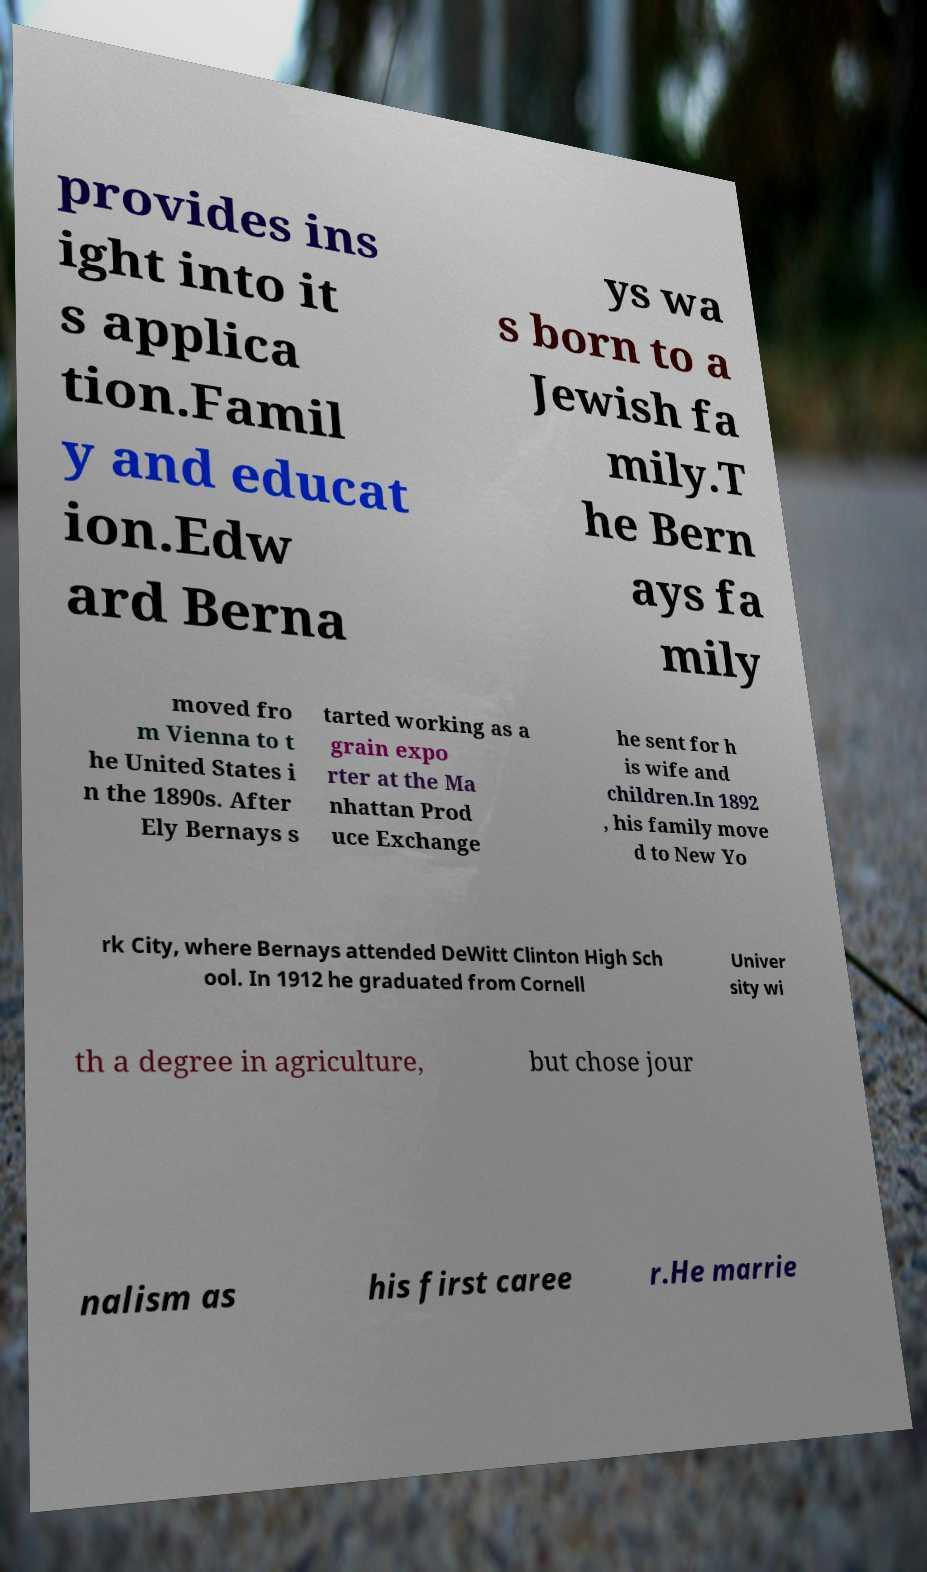Could you assist in decoding the text presented in this image and type it out clearly? provides ins ight into it s applica tion.Famil y and educat ion.Edw ard Berna ys wa s born to a Jewish fa mily.T he Bern ays fa mily moved fro m Vienna to t he United States i n the 1890s. After Ely Bernays s tarted working as a grain expo rter at the Ma nhattan Prod uce Exchange he sent for h is wife and children.In 1892 , his family move d to New Yo rk City, where Bernays attended DeWitt Clinton High Sch ool. In 1912 he graduated from Cornell Univer sity wi th a degree in agriculture, but chose jour nalism as his first caree r.He marrie 